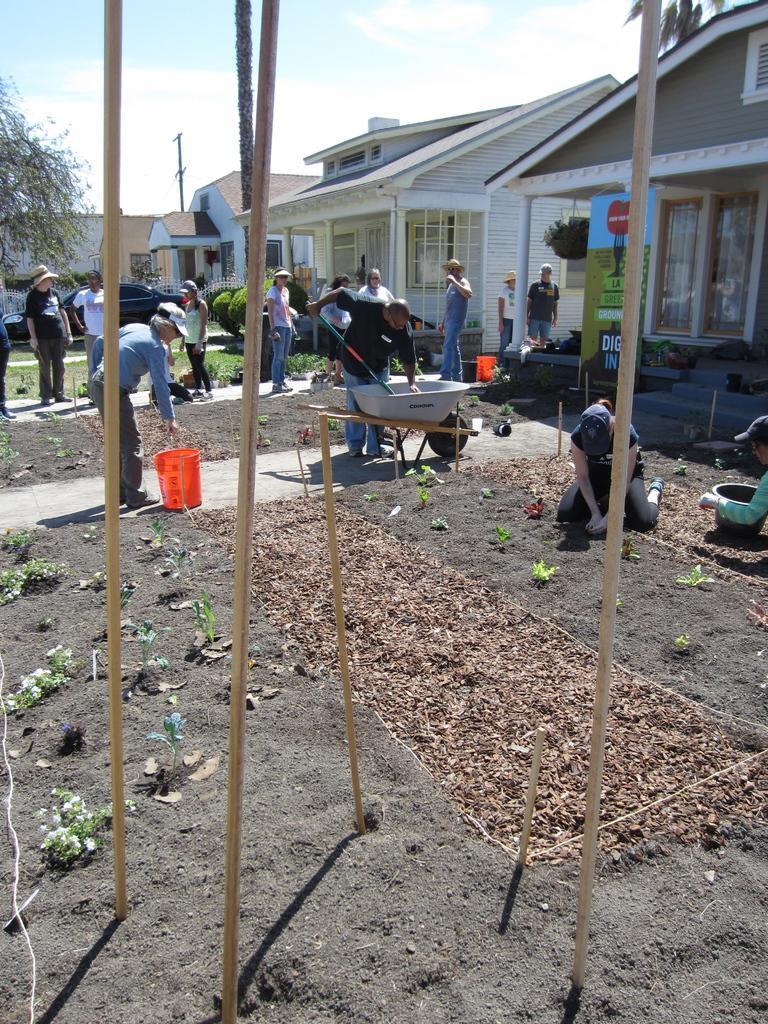In one or two sentences, can you explain what this image depicts? In this image we can see people and there is a container. On the left there is a car. We can see a bucket and there are shrubs and we can see trees. In the background there are buildings, poles and sky. 